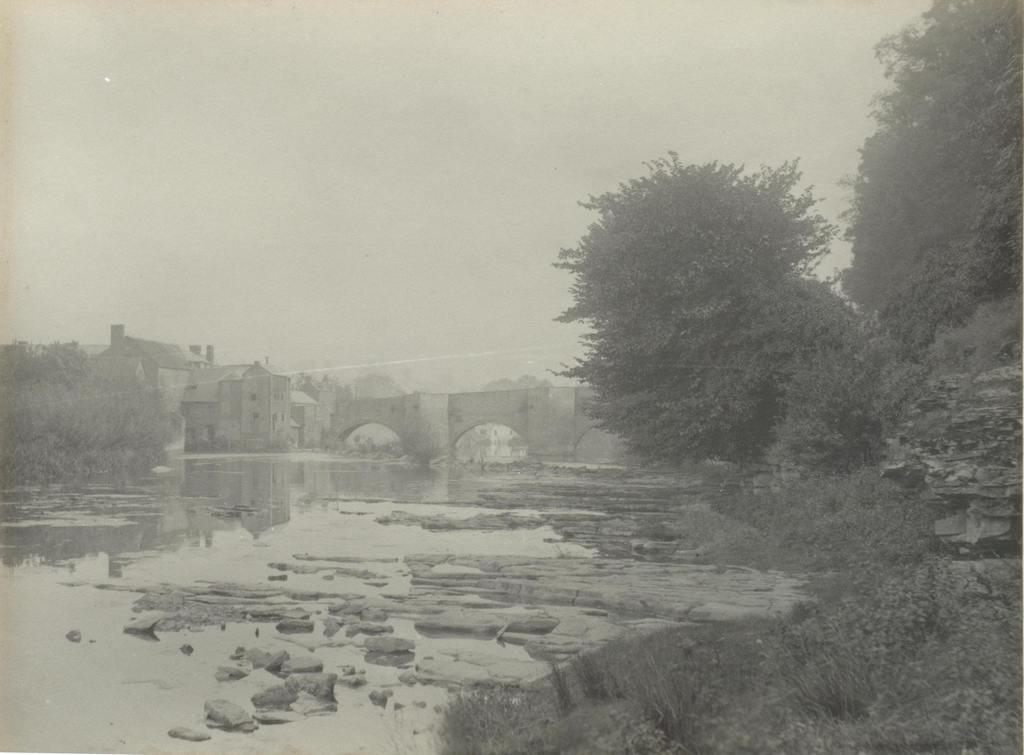How would you summarize this image in a sentence or two? This is a black and white image, where we can see a bridge above the water, on the right side of the image there are trees and on the left side of the image there are trees, plants and houses. 